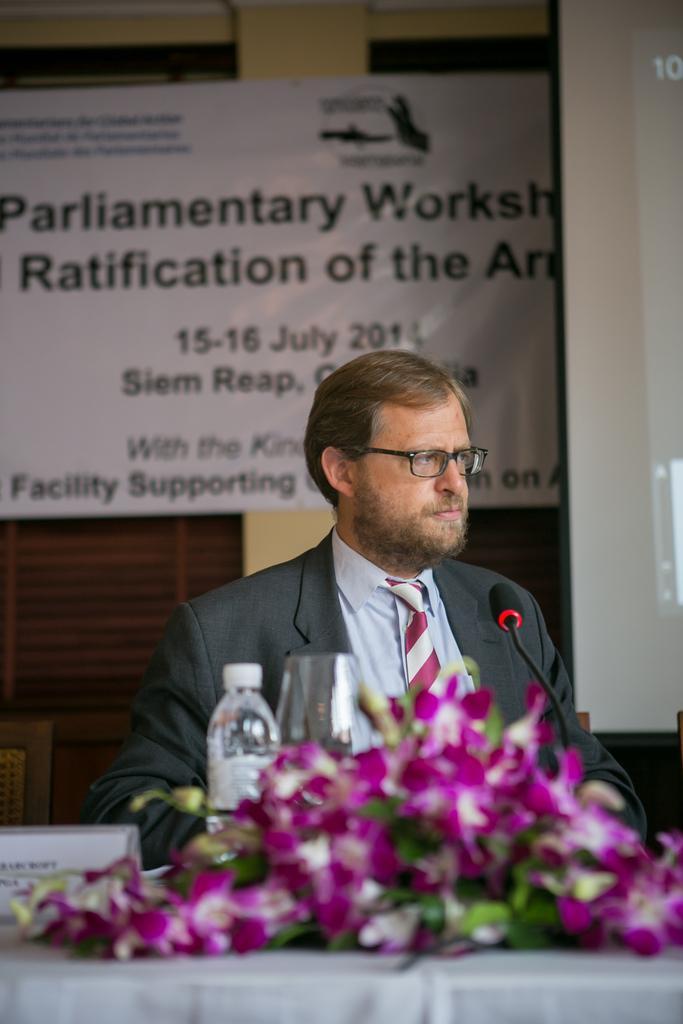How would you summarize this image in a sentence or two? In this image there is a man sitting on chair, in front of him there is a table, on that table there is bottle, flowers, in the background there is a wall to that wall there is a poster on that poster there is some text. 